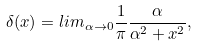Convert formula to latex. <formula><loc_0><loc_0><loc_500><loc_500>\delta ( x ) = l i m _ { \alpha \to 0 } \frac { 1 } { \pi } \frac { \alpha } { \alpha ^ { 2 } + x ^ { 2 } } ,</formula> 